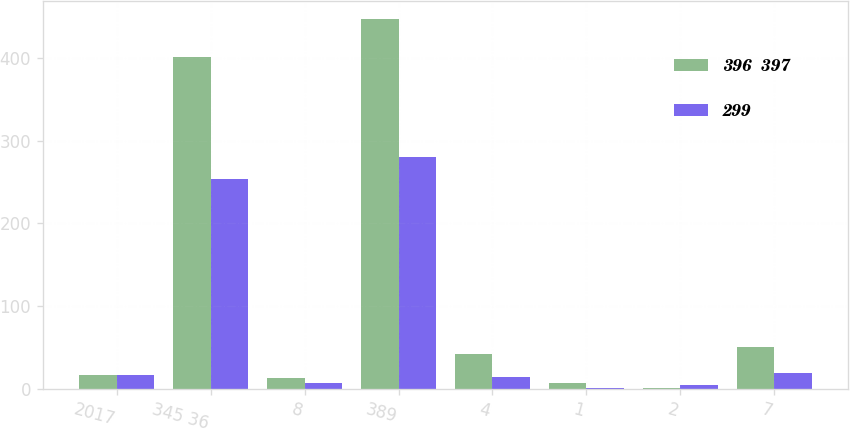<chart> <loc_0><loc_0><loc_500><loc_500><stacked_bar_chart><ecel><fcel>2017<fcel>345 36<fcel>8<fcel>389<fcel>4<fcel>1<fcel>2<fcel>7<nl><fcel>396  397<fcel>16.5<fcel>401<fcel>13<fcel>447<fcel>42<fcel>7<fcel>1<fcel>50<nl><fcel>299<fcel>16.5<fcel>253<fcel>7<fcel>280<fcel>14<fcel>1<fcel>4<fcel>19<nl></chart> 